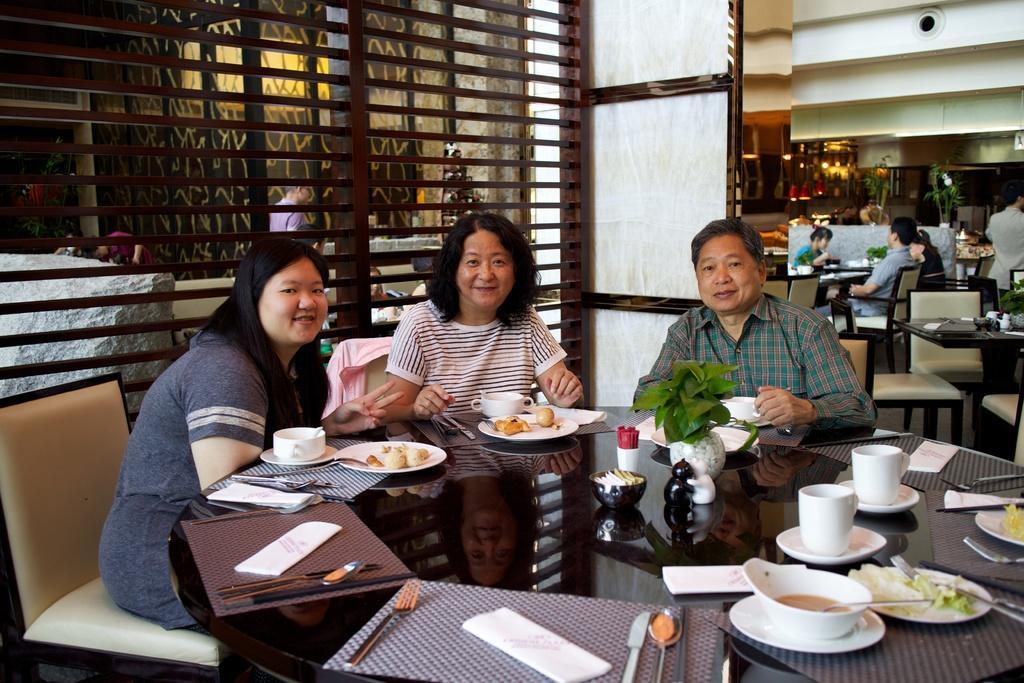Please provide a concise description of this image. There are three people sitting in the chairs in front of a table on which some tissues, plates, bowls, cups were placed. All of them were smiling. In the background there are some people sitting. We can observe a lights here. 